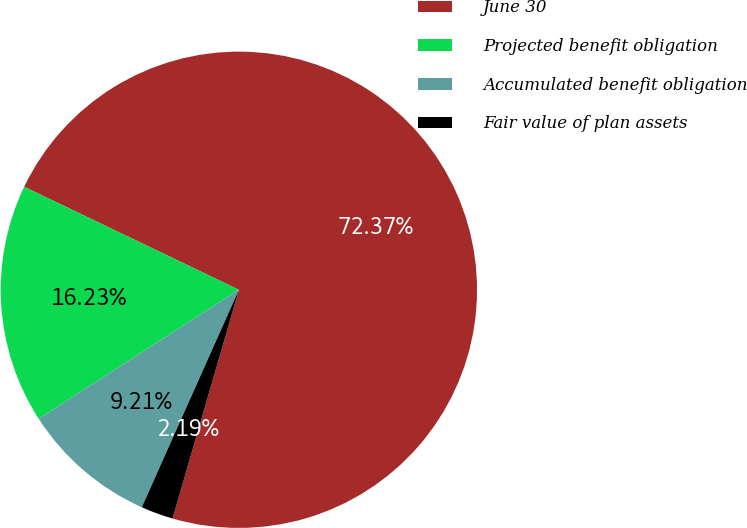Convert chart to OTSL. <chart><loc_0><loc_0><loc_500><loc_500><pie_chart><fcel>June 30<fcel>Projected benefit obligation<fcel>Accumulated benefit obligation<fcel>Fair value of plan assets<nl><fcel>72.38%<fcel>16.23%<fcel>9.21%<fcel>2.19%<nl></chart> 